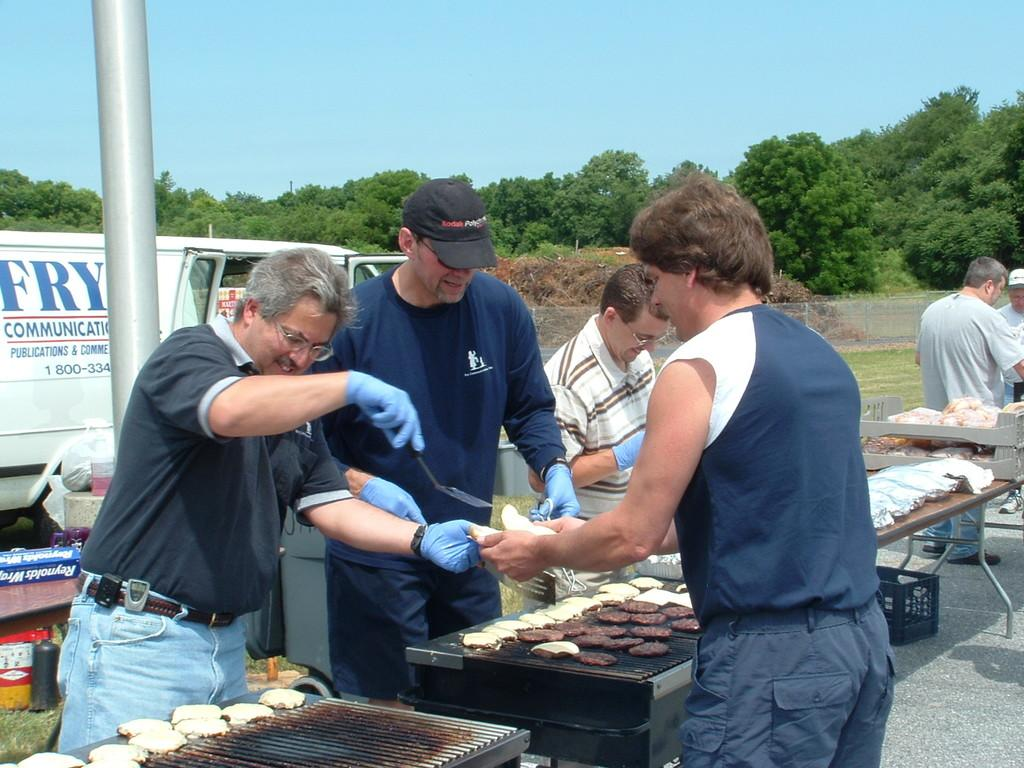<image>
Offer a succinct explanation of the picture presented. men grilling hamburgers infront of a fry communications white van 